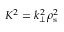Convert formula to latex. <formula><loc_0><loc_0><loc_500><loc_500>K ^ { 2 } = k _ { \bot } ^ { 2 } \rho _ { s } ^ { 2 }</formula> 